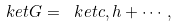Convert formula to latex. <formula><loc_0><loc_0><loc_500><loc_500>\ k e t { G } = \ k e t { c , h } + \cdots ,</formula> 